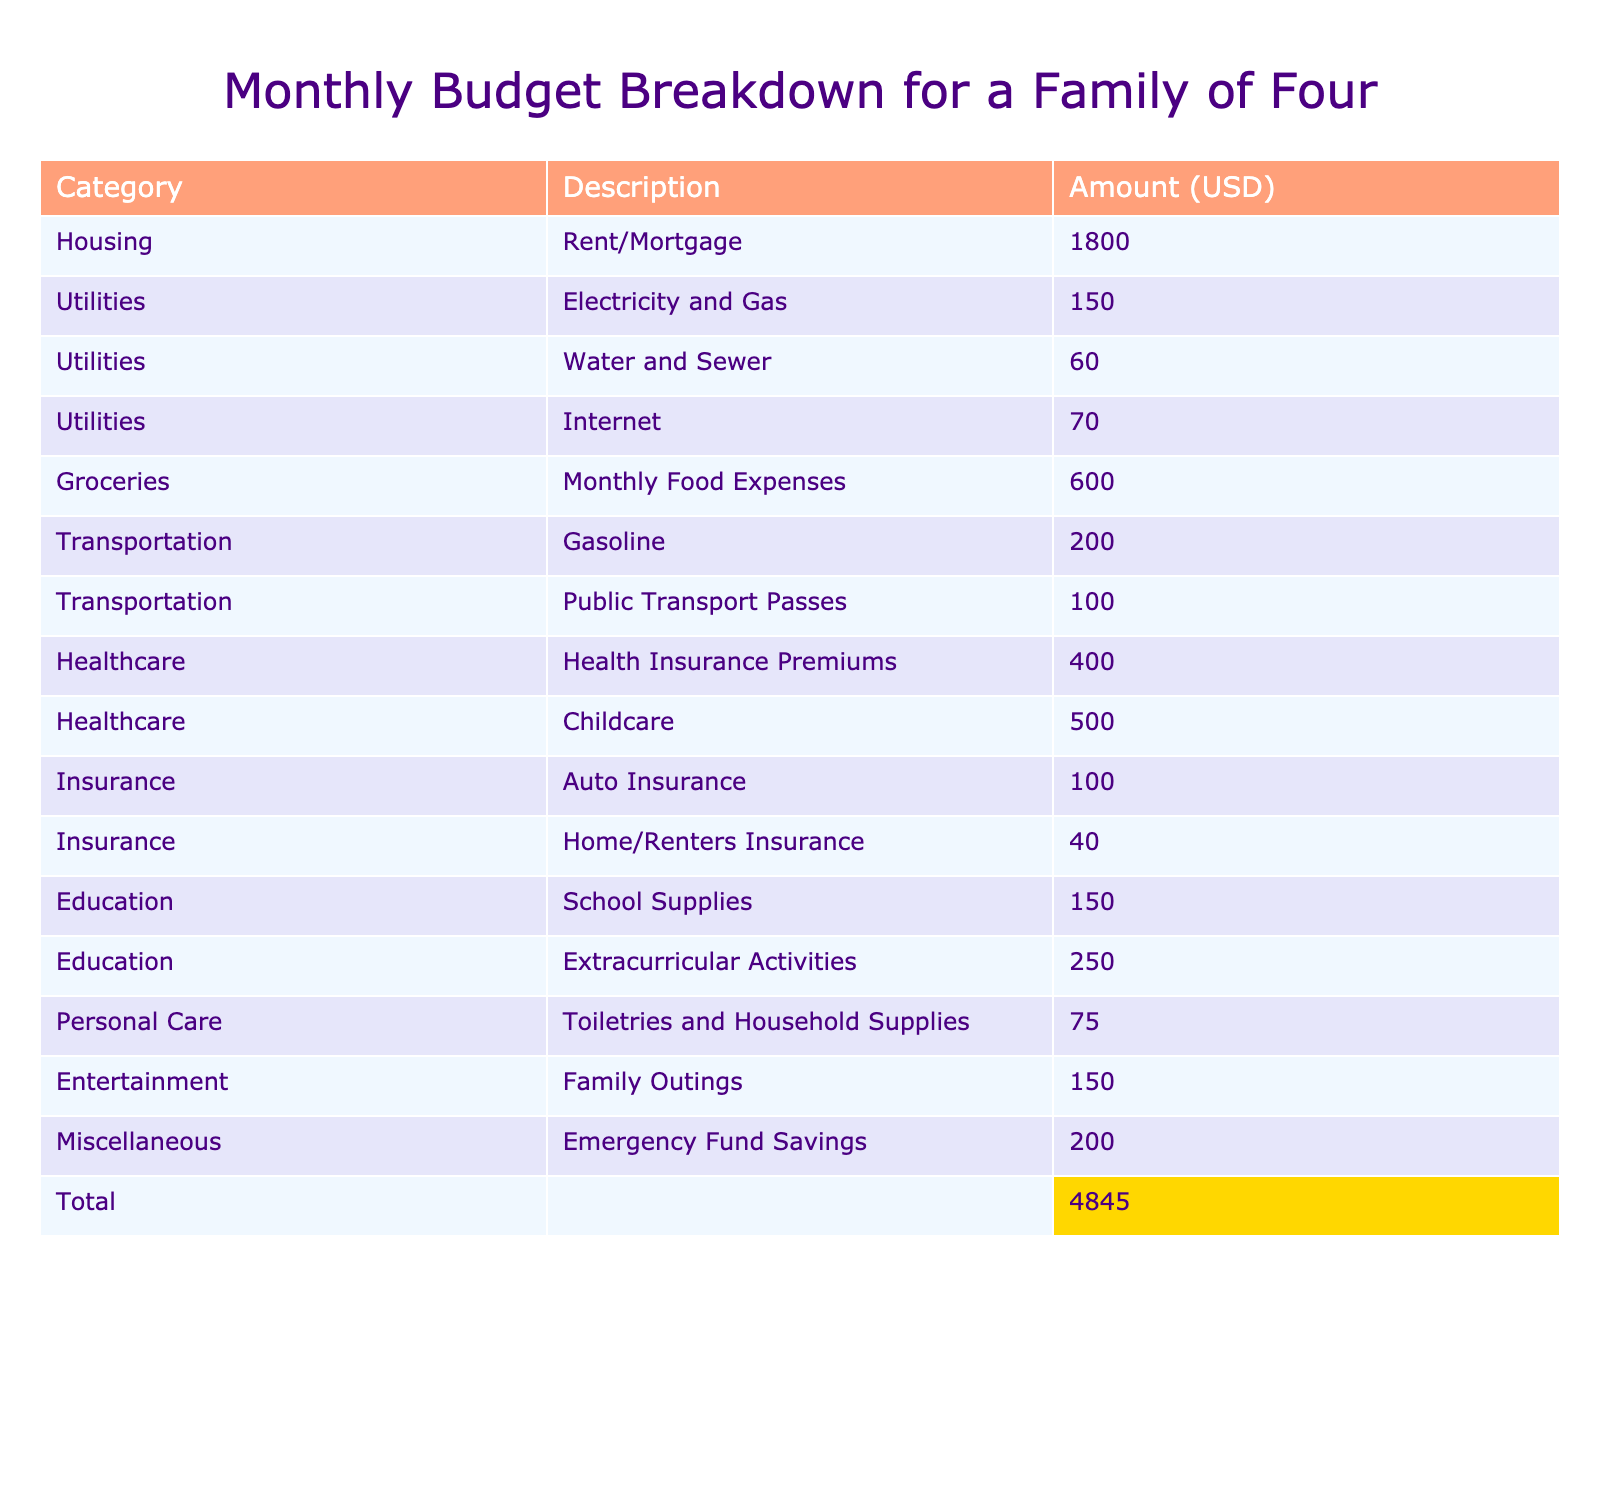What is the total amount allocated for Healthcare? In the Healthcare category, two entries are listed: Health Insurance Premiums for $400 and Childcare for $500. Summing these amounts gives $400 + $500 = $900.
Answer: $900 What is the highest expense category based on the table? By examining all the categories, Housing has the highest amount listed at $1800 for Rent/Mortgage.
Answer: Housing How much is spent on Education compared to Transportation? Education totals $400 (School Supplies for $150 and Extracurricular Activities for $250) while Transportation totals $300 (Gasoline for $200 and Public Transport Passes for $100). The difference is $400 - $300 = $100, meaning Education is $100 more.
Answer: Education is $100 more What percentage of the total budget is allocated to Groceries? The total budget is $4,550 (sum of all amounts). Groceries cost $600. To find the percentage, calculate ($600 / $4550) * 100, which is approximately 13.19%.
Answer: 13.19% Is the total spent on Miscellaneous the same as the spent on Entertainment? The total for Miscellaneous is $200 (Emergency Fund Savings) and the total for Entertainment is also $150 (Family Outings). Since $200 is not equal to $150, the statement is false.
Answer: No What is the combined total for Utilities? Utilities include three entries: Electricity and Gas for $150, Water and Sewer for $60, and Internet for $70. Summing these gives $150 + $60 + $70 = $280.
Answer: $280 How much more is spent on Childcare than on Auto Insurance? Childcare costs $500 while Auto Insurance costs $100. The difference is $500 - $100 = $400, indicating Childcare costs $400 more.
Answer: $400 What is the total budget for the family, and how does it compare to Housing? The total budget is $4,550, and Housing costs $1,800. This shows that Housing accounts for approximately 39.56% of the total budget, calculated as ($1800 / $4550) * 100.
Answer: $4,550; 39.56% How much do Utilities contribute to the overall budget? The total for Utilities is $280, and the overall budget is $4,550. To find the contribution percentage, calculate ($280 / $4550) * 100, which is about 6.15%.
Answer: 6.15% Which category has the least amount spent? The lowest amount is found in the Home/Renters Insurance category, which is $40. Sorting through the categories, no other amount is less.
Answer: Home/Renters Insurance at $40 